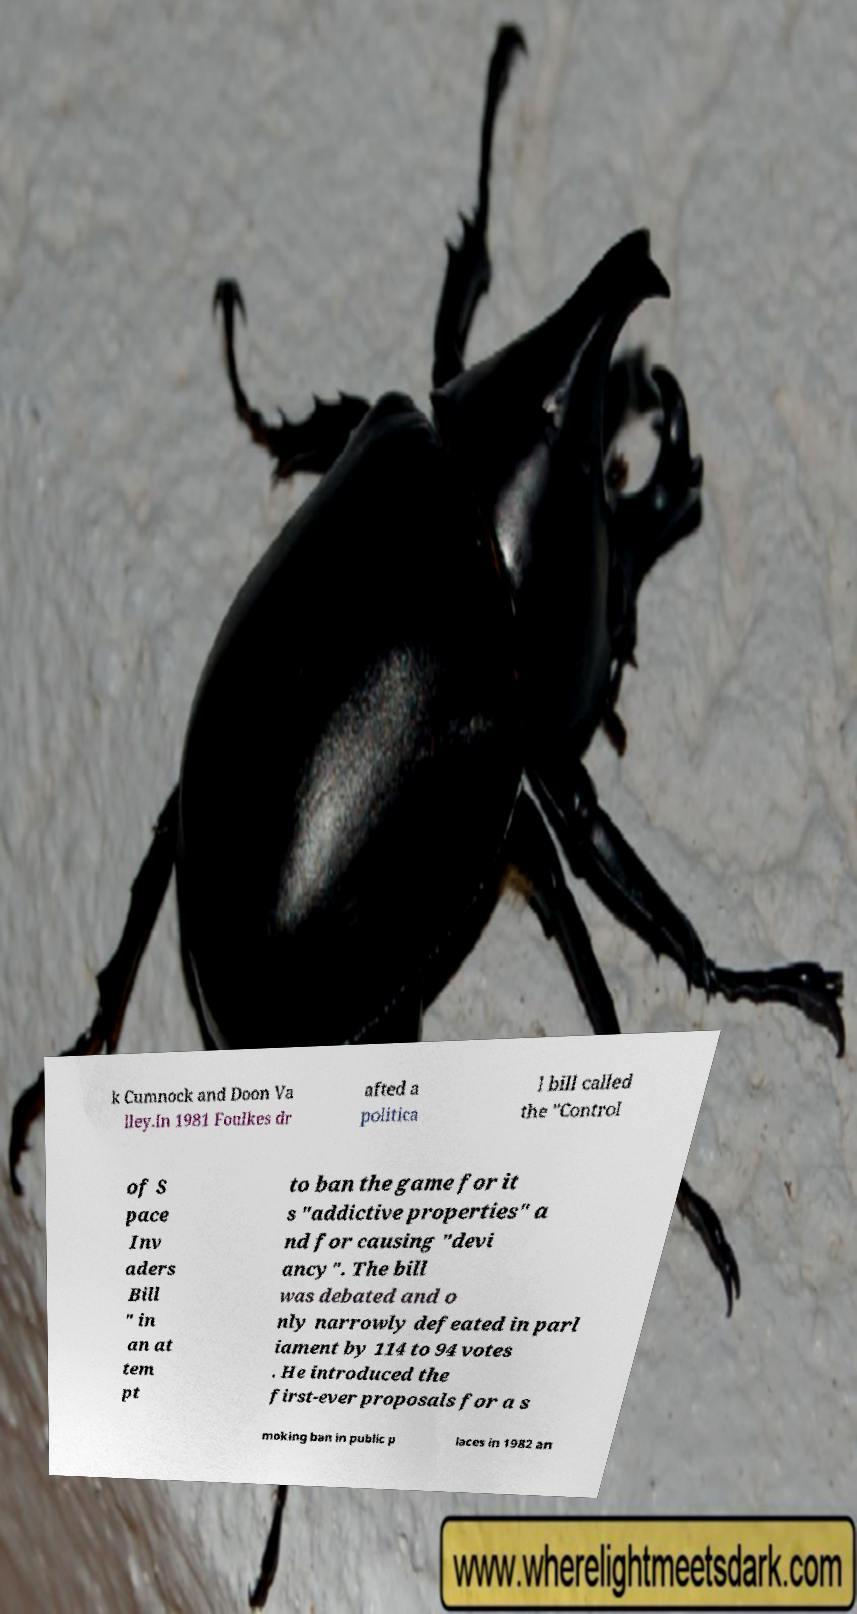Can you read and provide the text displayed in the image?This photo seems to have some interesting text. Can you extract and type it out for me? k Cumnock and Doon Va lley.In 1981 Foulkes dr afted a politica l bill called the "Control of S pace Inv aders Bill " in an at tem pt to ban the game for it s "addictive properties" a nd for causing "devi ancy". The bill was debated and o nly narrowly defeated in parl iament by 114 to 94 votes . He introduced the first-ever proposals for a s moking ban in public p laces in 1982 an 